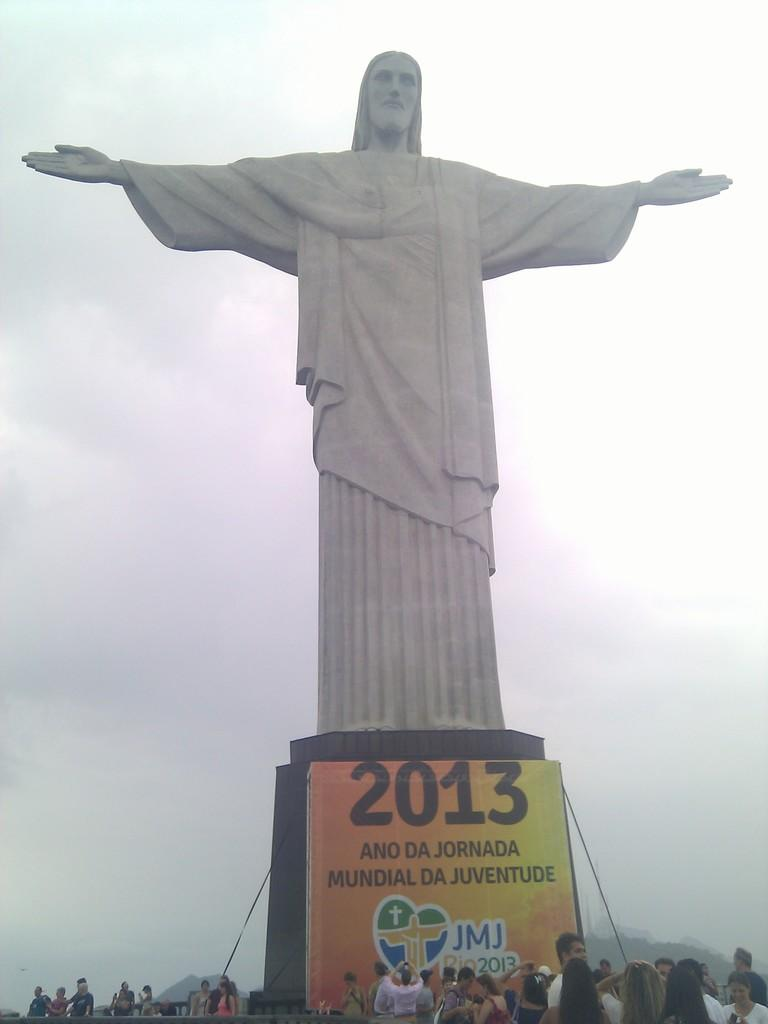Provide a one-sentence caption for the provided image. A large statue of Jesus sits high above a crowd of people with a banner that says 2013. 